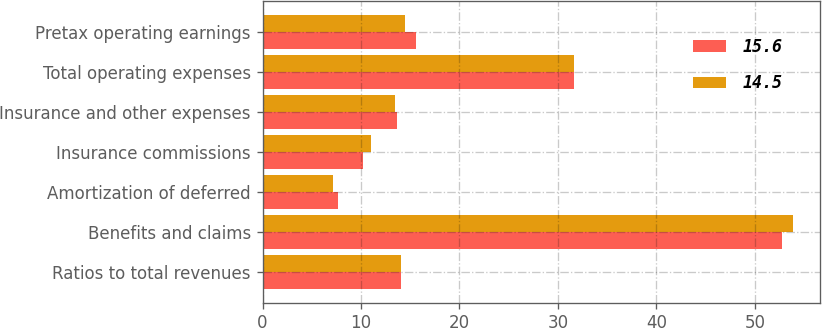Convert chart to OTSL. <chart><loc_0><loc_0><loc_500><loc_500><stacked_bar_chart><ecel><fcel>Ratios to total revenues<fcel>Benefits and claims<fcel>Amortization of deferred<fcel>Insurance commissions<fcel>Insurance and other expenses<fcel>Total operating expenses<fcel>Pretax operating earnings<nl><fcel>15.6<fcel>14.1<fcel>52.8<fcel>7.7<fcel>10.2<fcel>13.7<fcel>31.6<fcel>15.6<nl><fcel>14.5<fcel>14.1<fcel>53.9<fcel>7.2<fcel>11<fcel>13.4<fcel>31.6<fcel>14.5<nl></chart> 